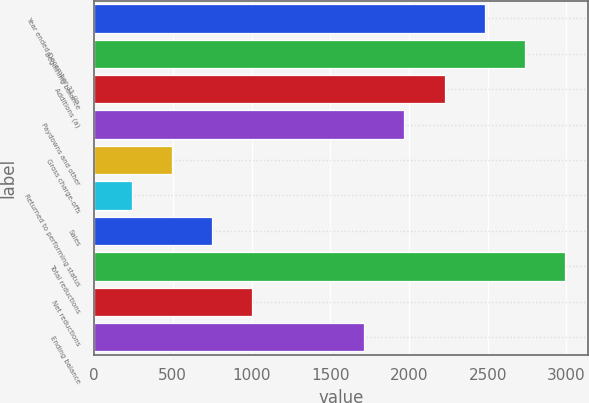Convert chart. <chart><loc_0><loc_0><loc_500><loc_500><bar_chart><fcel>Year ended December 31 (in<fcel>Beginning balance<fcel>Additions (a)<fcel>Paydowns and other<fcel>Gross charge-offs<fcel>Returned to performing status<fcel>Sales<fcel>Total reductions<fcel>Net reductions<fcel>Ending balance<nl><fcel>2480.2<fcel>2734.6<fcel>2225.8<fcel>1971.4<fcel>494.4<fcel>240<fcel>748.8<fcel>2989<fcel>1003.2<fcel>1717<nl></chart> 